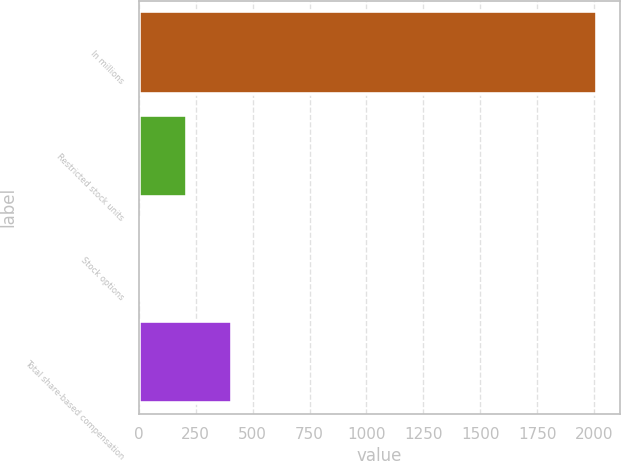<chart> <loc_0><loc_0><loc_500><loc_500><bar_chart><fcel>In millions<fcel>Restricted stock units<fcel>Stock options<fcel>Total share-based compensation<nl><fcel>2014<fcel>211.3<fcel>11<fcel>411.6<nl></chart> 